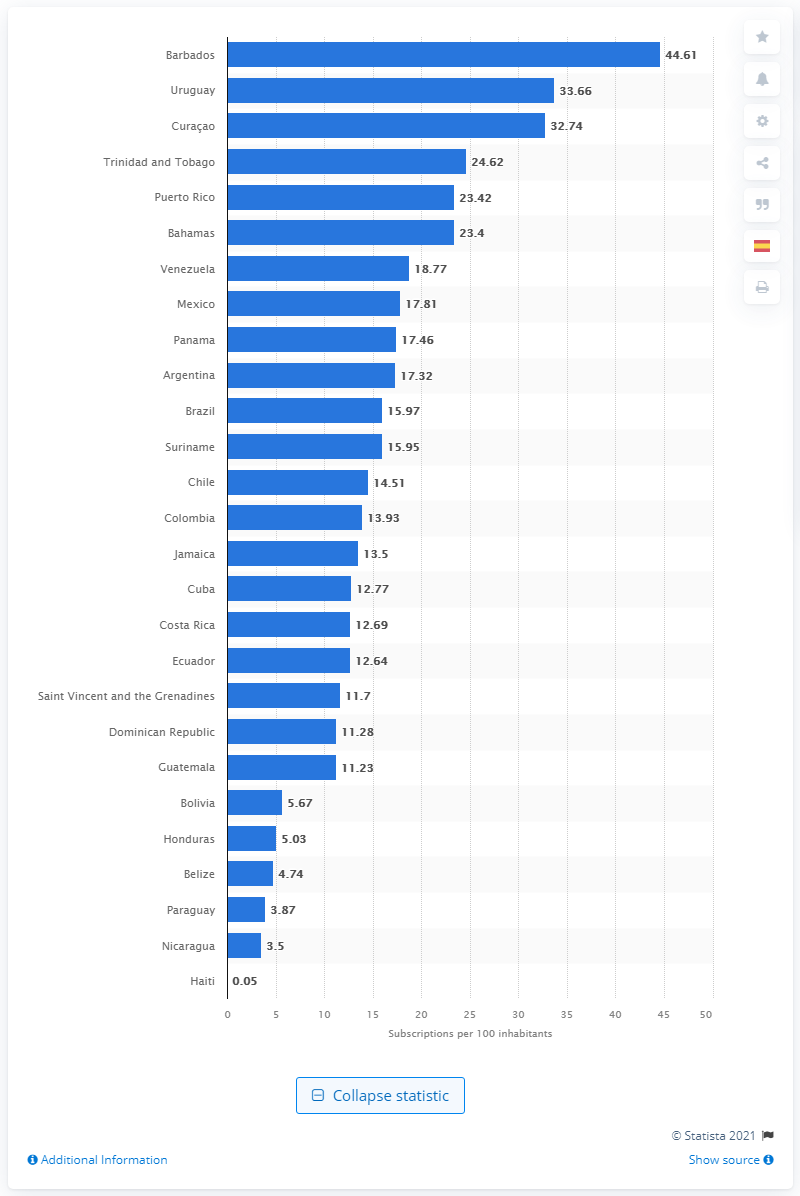Point out several critical features in this image. According to a 2019 survey, Barbados had the highest fixed-line telephone penetration rate among all countries. In 2019, there were 44.61 fixed phone subscriptions per 100 Barbadians. Uruguay had the highest fixed-line phone penetration rate in 2019. 